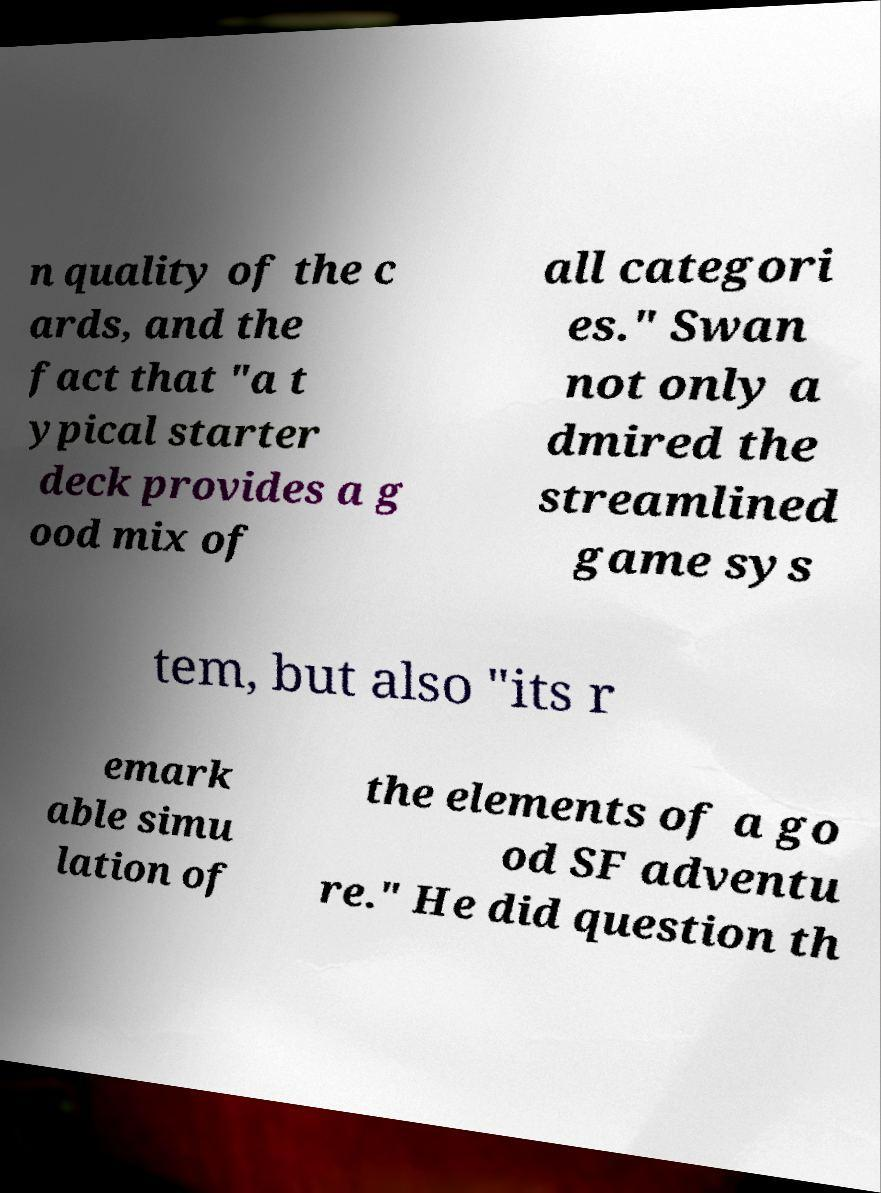Please identify and transcribe the text found in this image. n quality of the c ards, and the fact that "a t ypical starter deck provides a g ood mix of all categori es." Swan not only a dmired the streamlined game sys tem, but also "its r emark able simu lation of the elements of a go od SF adventu re." He did question th 